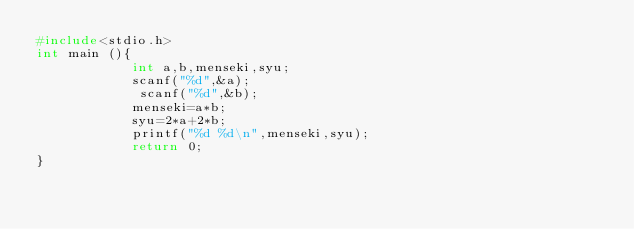<code> <loc_0><loc_0><loc_500><loc_500><_C++_>#include<stdio.h>
int main (){
            int a,b,menseki,syu;
            scanf("%d",&a);
             scanf("%d",&b);
            menseki=a*b;
            syu=2*a+2*b;
            printf("%d %d\n",menseki,syu);
            return 0;
}</code> 